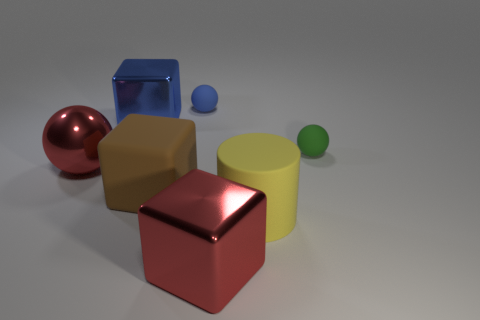Add 1 matte objects. How many objects exist? 8 Subtract all cylinders. How many objects are left? 6 Add 3 red metal blocks. How many red metal blocks are left? 4 Add 2 large yellow rubber cylinders. How many large yellow rubber cylinders exist? 3 Subtract 0 brown balls. How many objects are left? 7 Subtract all large cubes. Subtract all big spheres. How many objects are left? 3 